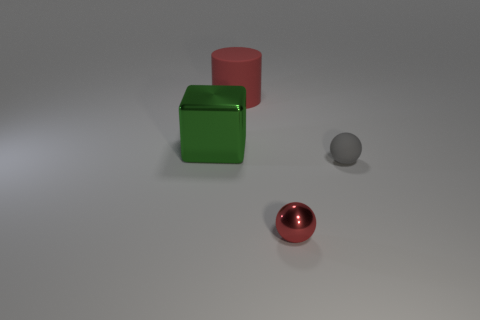Does the tiny thing that is in front of the small gray rubber sphere have the same shape as the metal thing behind the gray object?
Your response must be concise. No. Is there anything else that is the same shape as the big green thing?
Provide a short and direct response. No. There is another small object that is made of the same material as the green thing; what is its shape?
Provide a succinct answer. Sphere. Are there an equal number of large matte cylinders that are in front of the rubber cylinder and small red objects?
Make the answer very short. No. Is the material of the red object that is in front of the big rubber thing the same as the thing left of the large red matte cylinder?
Give a very brief answer. Yes. There is a object behind the metal thing behind the red ball; what is its shape?
Keep it short and to the point. Cylinder. There is a small ball that is made of the same material as the big green thing; what is its color?
Give a very brief answer. Red. Does the big metal cube have the same color as the large cylinder?
Offer a very short reply. No. What shape is the metallic object that is the same size as the red matte cylinder?
Your answer should be very brief. Cube. The block is what size?
Provide a succinct answer. Large. 